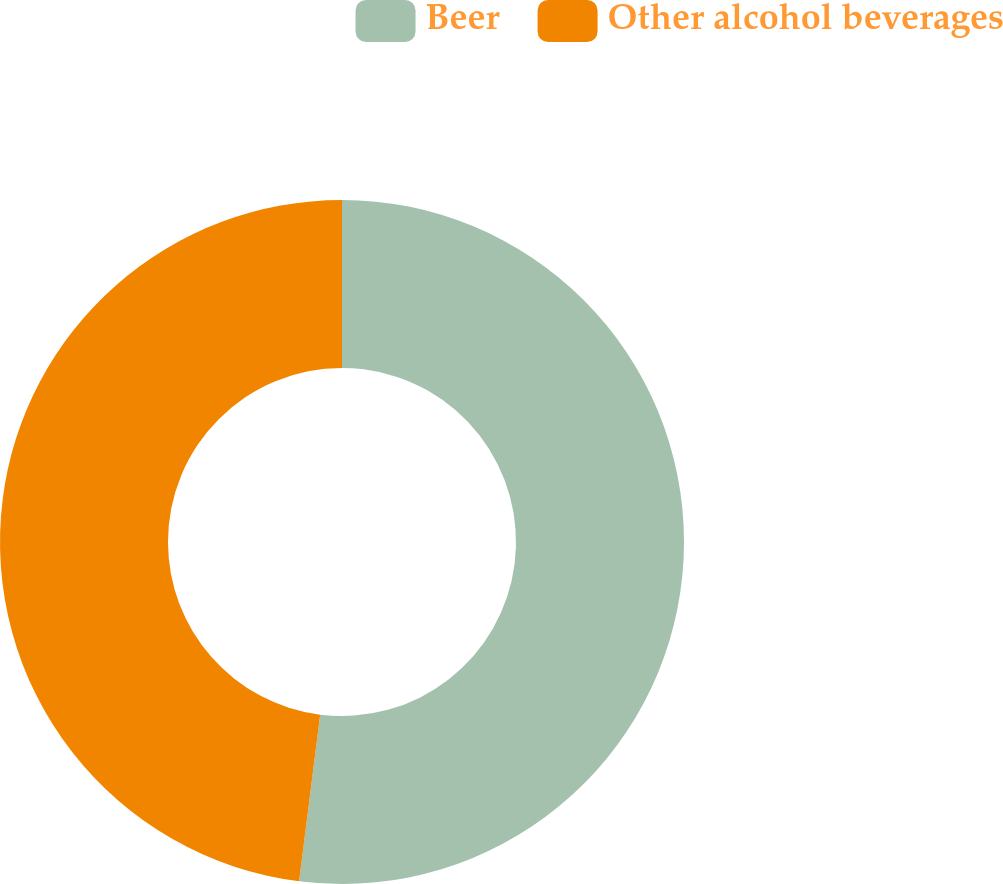Convert chart. <chart><loc_0><loc_0><loc_500><loc_500><pie_chart><fcel>Beer<fcel>Other alcohol beverages<nl><fcel>52.0%<fcel>48.0%<nl></chart> 